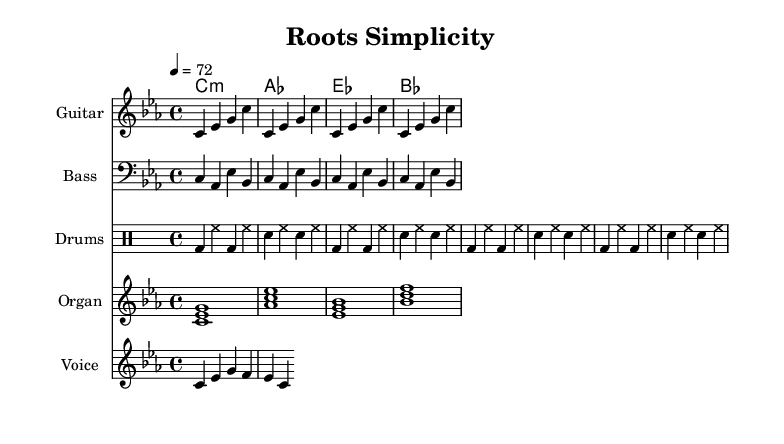What is the key signature of this music? The key signature is C minor, which is indicated by the presence of three flats (B♭, E♭, and A♭) in the key signature.
Answer: C minor What is the time signature of this music? The time signature is 4/4, which means there are four beats in a measure and a quarter note receives one beat, as indicated at the beginning of the piece.
Answer: 4/4 What is the tempo marking of this music? The tempo marking is 72 beats per minute, as specified in the score with the instruction "4 = 72." This indicates a moderate pace for the music.
Answer: 72 What instruments are used in this piece? The instruments listed are Guitar, Bass, Drums, and Organ. Each instrument is specified in its own staff, showcasing a typical arrangement in reggae music with a focus on rhythm and harmony.
Answer: Guitar, Bass, Drums, Organ How many times is the guitar riff repeated? The guitar riff is repeated four times, as indicated by the "repeat unfold 4" notation in the score. This emphasizes the minimalist approach characteristic of reggae instrumentals.
Answer: 4 What is the primary lyrical content of this piece? The lyric provided is "Simple roots growing strong," which reflects the sparse lyrical content typical of minimalist reggae, where the focus is often on repetitive themes.
Answer: Simple roots growing strong What chord is played in the organ part? The organ part plays a C minor chord, as indicated by the chord mode notation "c1:m," which represents a C minor quality. This reinforces the key of the piece.
Answer: C minor 